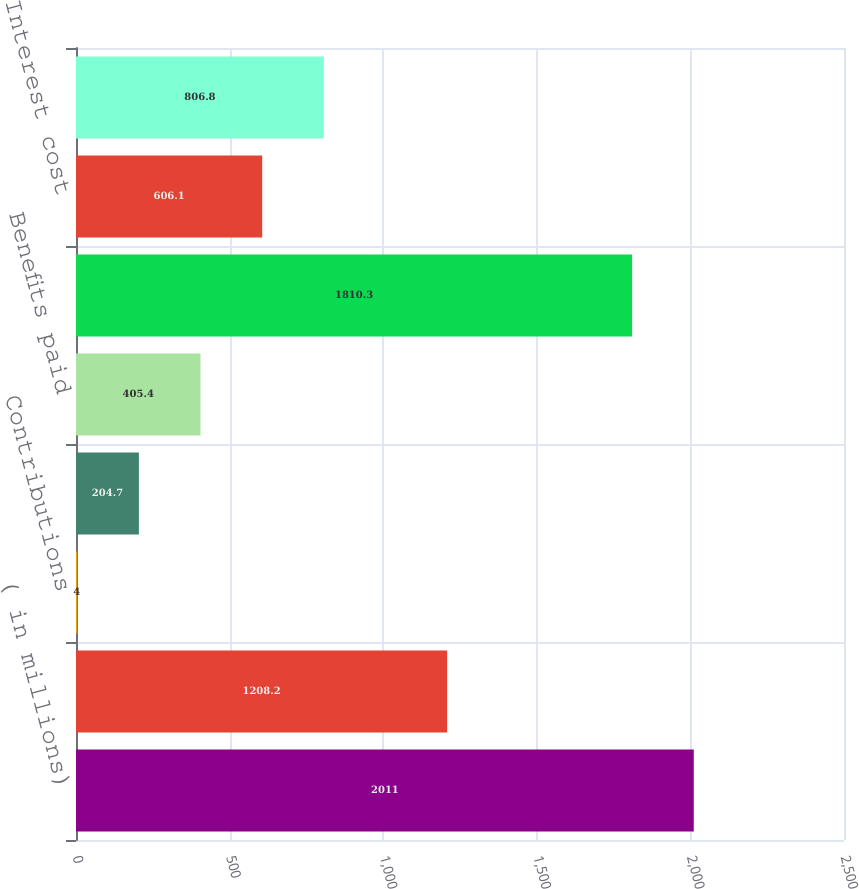<chart> <loc_0><loc_0><loc_500><loc_500><bar_chart><fcel>( in millions)<fcel>Fair value of plan assets at<fcel>Contributions<fcel>Settlement<fcel>Benefits paid<fcel>Projected benefit obligation<fcel>Interest cost<fcel>Actuarial loss<nl><fcel>2011<fcel>1208.2<fcel>4<fcel>204.7<fcel>405.4<fcel>1810.3<fcel>606.1<fcel>806.8<nl></chart> 